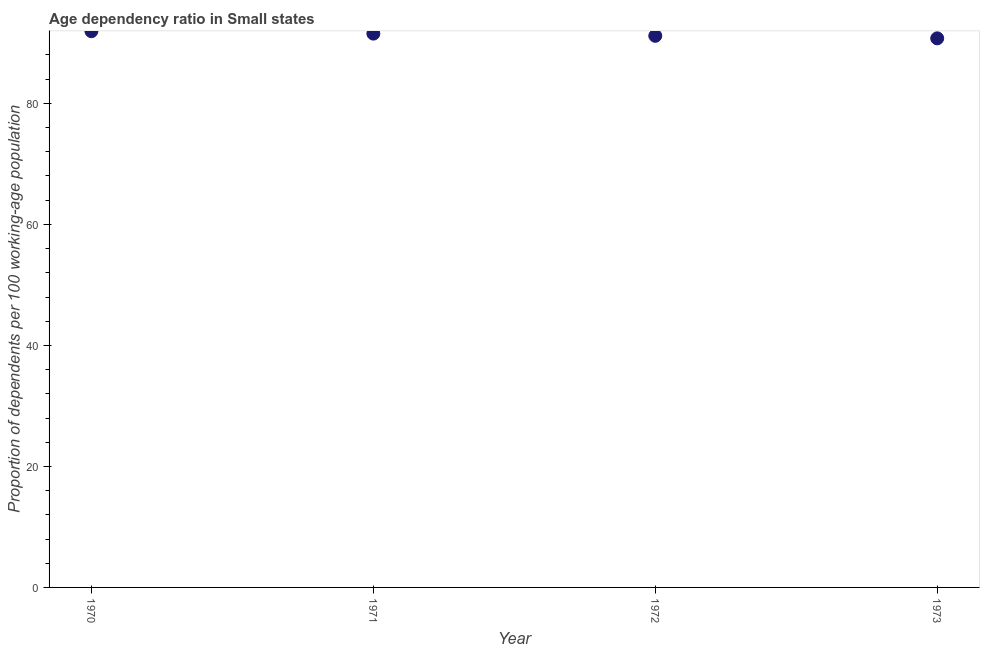What is the age dependency ratio in 1971?
Keep it short and to the point. 91.53. Across all years, what is the maximum age dependency ratio?
Your answer should be compact. 91.93. Across all years, what is the minimum age dependency ratio?
Keep it short and to the point. 90.75. What is the sum of the age dependency ratio?
Provide a short and direct response. 365.38. What is the difference between the age dependency ratio in 1971 and 1973?
Offer a very short reply. 0.78. What is the average age dependency ratio per year?
Your answer should be compact. 91.35. What is the median age dependency ratio?
Provide a succinct answer. 91.35. Do a majority of the years between 1971 and 1970 (inclusive) have age dependency ratio greater than 64 ?
Offer a very short reply. No. What is the ratio of the age dependency ratio in 1970 to that in 1971?
Make the answer very short. 1. Is the age dependency ratio in 1971 less than that in 1972?
Give a very brief answer. No. What is the difference between the highest and the second highest age dependency ratio?
Ensure brevity in your answer.  0.4. Is the sum of the age dependency ratio in 1971 and 1973 greater than the maximum age dependency ratio across all years?
Give a very brief answer. Yes. What is the difference between the highest and the lowest age dependency ratio?
Your answer should be compact. 1.18. In how many years, is the age dependency ratio greater than the average age dependency ratio taken over all years?
Ensure brevity in your answer.  2. What is the difference between two consecutive major ticks on the Y-axis?
Provide a short and direct response. 20. Does the graph contain any zero values?
Ensure brevity in your answer.  No. Does the graph contain grids?
Your response must be concise. No. What is the title of the graph?
Provide a succinct answer. Age dependency ratio in Small states. What is the label or title of the Y-axis?
Offer a very short reply. Proportion of dependents per 100 working-age population. What is the Proportion of dependents per 100 working-age population in 1970?
Your answer should be compact. 91.93. What is the Proportion of dependents per 100 working-age population in 1971?
Provide a short and direct response. 91.53. What is the Proportion of dependents per 100 working-age population in 1972?
Make the answer very short. 91.17. What is the Proportion of dependents per 100 working-age population in 1973?
Provide a short and direct response. 90.75. What is the difference between the Proportion of dependents per 100 working-age population in 1970 and 1971?
Your response must be concise. 0.4. What is the difference between the Proportion of dependents per 100 working-age population in 1970 and 1972?
Provide a short and direct response. 0.76. What is the difference between the Proportion of dependents per 100 working-age population in 1970 and 1973?
Give a very brief answer. 1.18. What is the difference between the Proportion of dependents per 100 working-age population in 1971 and 1972?
Give a very brief answer. 0.36. What is the difference between the Proportion of dependents per 100 working-age population in 1971 and 1973?
Make the answer very short. 0.78. What is the difference between the Proportion of dependents per 100 working-age population in 1972 and 1973?
Give a very brief answer. 0.42. What is the ratio of the Proportion of dependents per 100 working-age population in 1971 to that in 1973?
Your response must be concise. 1.01. What is the ratio of the Proportion of dependents per 100 working-age population in 1972 to that in 1973?
Provide a short and direct response. 1. 